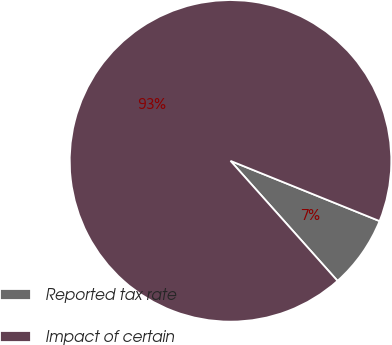Convert chart. <chart><loc_0><loc_0><loc_500><loc_500><pie_chart><fcel>Reported tax rate<fcel>Impact of certain<nl><fcel>7.3%<fcel>92.7%<nl></chart> 